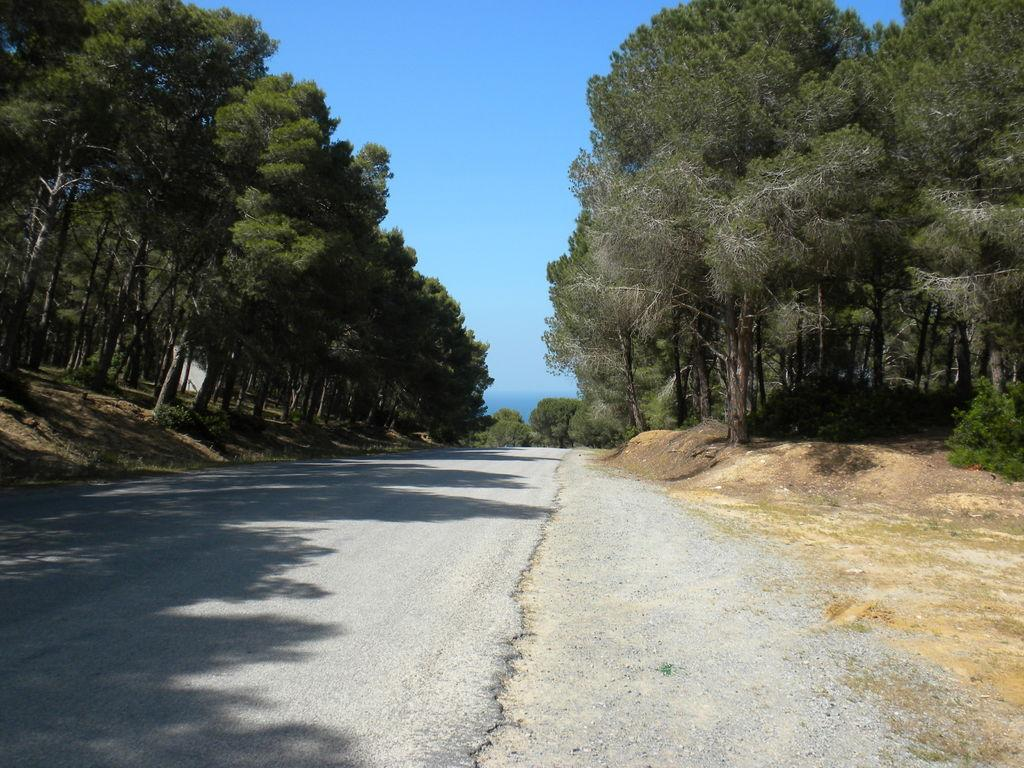What is the main feature of the image? There is a road in the image. What can be seen on both sides of the road? Trees are present on both sides of the road. What is visible above the road and trees? The sky is visible in the image. What can be observed in the sky? Clouds are present in the sky. What language is spoken by the trees on the side of the road? Trees do not speak any language, so this question cannot be answered. 